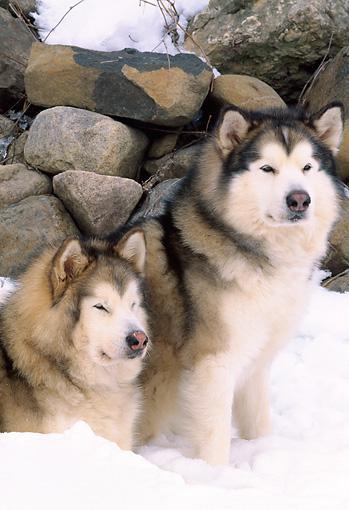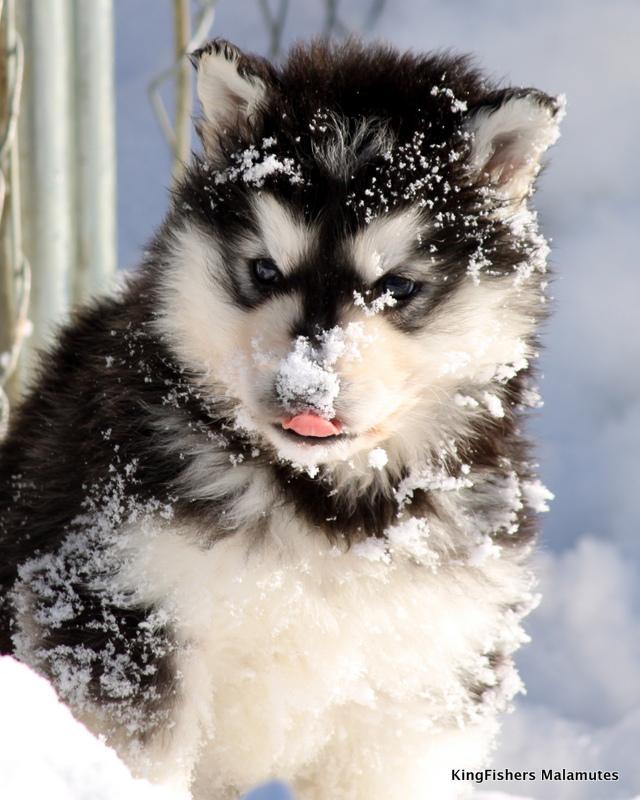The first image is the image on the left, the second image is the image on the right. For the images shown, is this caption "One of the images contains one Husky dog and the other image contains two Husky dogs." true? Answer yes or no. Yes. The first image is the image on the left, the second image is the image on the right. Given the left and right images, does the statement "One image features a dog sitting upright to the right of a dog in a reclining pose, and the other image includes a dog with snow on its fur." hold true? Answer yes or no. Yes. 